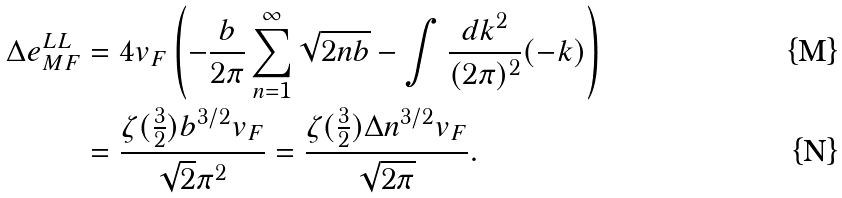<formula> <loc_0><loc_0><loc_500><loc_500>\Delta e _ { M F } ^ { L L } & = 4 v _ { F } \left ( - \frac { b } { 2 \pi } \sum _ { n = 1 } ^ { \infty } \sqrt { 2 n b } - \int \frac { d k ^ { 2 } } { ( 2 \pi ) ^ { 2 } } ( - k ) \right ) \\ & = \frac { \zeta ( \frac { 3 } { 2 } ) b ^ { 3 / 2 } v _ { F } } { \sqrt { 2 } \pi ^ { 2 } } = \frac { \zeta ( \frac { 3 } { 2 } ) \Delta n ^ { 3 / 2 } v _ { F } } { \sqrt { 2 \pi } } .</formula> 